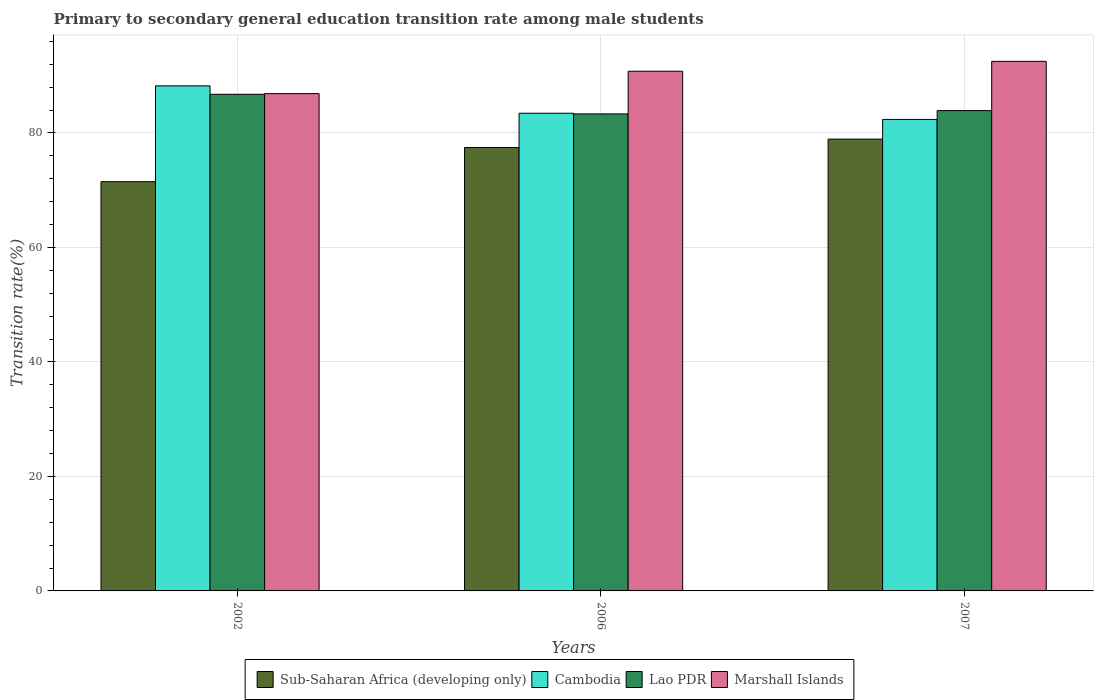How many different coloured bars are there?
Provide a succinct answer. 4. What is the label of the 3rd group of bars from the left?
Make the answer very short. 2007. What is the transition rate in Marshall Islands in 2007?
Provide a succinct answer. 92.51. Across all years, what is the maximum transition rate in Sub-Saharan Africa (developing only)?
Your response must be concise. 78.93. Across all years, what is the minimum transition rate in Marshall Islands?
Give a very brief answer. 86.88. In which year was the transition rate in Cambodia maximum?
Provide a short and direct response. 2002. What is the total transition rate in Marshall Islands in the graph?
Your response must be concise. 270.17. What is the difference between the transition rate in Sub-Saharan Africa (developing only) in 2006 and that in 2007?
Offer a terse response. -1.47. What is the difference between the transition rate in Sub-Saharan Africa (developing only) in 2007 and the transition rate in Cambodia in 2006?
Your answer should be very brief. -4.52. What is the average transition rate in Sub-Saharan Africa (developing only) per year?
Your response must be concise. 75.96. In the year 2002, what is the difference between the transition rate in Sub-Saharan Africa (developing only) and transition rate in Lao PDR?
Provide a short and direct response. -15.27. In how many years, is the transition rate in Cambodia greater than 8 %?
Your answer should be compact. 3. What is the ratio of the transition rate in Cambodia in 2006 to that in 2007?
Your answer should be very brief. 1.01. What is the difference between the highest and the second highest transition rate in Marshall Islands?
Provide a succinct answer. 1.73. What is the difference between the highest and the lowest transition rate in Marshall Islands?
Offer a very short reply. 5.64. In how many years, is the transition rate in Cambodia greater than the average transition rate in Cambodia taken over all years?
Provide a succinct answer. 1. What does the 2nd bar from the left in 2002 represents?
Provide a short and direct response. Cambodia. What does the 1st bar from the right in 2002 represents?
Offer a very short reply. Marshall Islands. Is it the case that in every year, the sum of the transition rate in Marshall Islands and transition rate in Sub-Saharan Africa (developing only) is greater than the transition rate in Cambodia?
Your response must be concise. Yes. How many bars are there?
Make the answer very short. 12. Are all the bars in the graph horizontal?
Your response must be concise. No. Are the values on the major ticks of Y-axis written in scientific E-notation?
Ensure brevity in your answer.  No. Does the graph contain any zero values?
Make the answer very short. No. Does the graph contain grids?
Offer a very short reply. Yes. How are the legend labels stacked?
Your answer should be very brief. Horizontal. What is the title of the graph?
Keep it short and to the point. Primary to secondary general education transition rate among male students. Does "Latvia" appear as one of the legend labels in the graph?
Your response must be concise. No. What is the label or title of the X-axis?
Ensure brevity in your answer.  Years. What is the label or title of the Y-axis?
Ensure brevity in your answer.  Transition rate(%). What is the Transition rate(%) in Sub-Saharan Africa (developing only) in 2002?
Provide a short and direct response. 71.49. What is the Transition rate(%) of Cambodia in 2002?
Provide a succinct answer. 88.23. What is the Transition rate(%) of Lao PDR in 2002?
Ensure brevity in your answer.  86.76. What is the Transition rate(%) in Marshall Islands in 2002?
Provide a short and direct response. 86.88. What is the Transition rate(%) of Sub-Saharan Africa (developing only) in 2006?
Give a very brief answer. 77.46. What is the Transition rate(%) of Cambodia in 2006?
Make the answer very short. 83.45. What is the Transition rate(%) of Lao PDR in 2006?
Your answer should be very brief. 83.33. What is the Transition rate(%) of Marshall Islands in 2006?
Provide a short and direct response. 90.78. What is the Transition rate(%) of Sub-Saharan Africa (developing only) in 2007?
Your answer should be compact. 78.93. What is the Transition rate(%) in Cambodia in 2007?
Ensure brevity in your answer.  82.37. What is the Transition rate(%) of Lao PDR in 2007?
Make the answer very short. 83.91. What is the Transition rate(%) of Marshall Islands in 2007?
Keep it short and to the point. 92.51. Across all years, what is the maximum Transition rate(%) in Sub-Saharan Africa (developing only)?
Your answer should be very brief. 78.93. Across all years, what is the maximum Transition rate(%) of Cambodia?
Make the answer very short. 88.23. Across all years, what is the maximum Transition rate(%) of Lao PDR?
Your answer should be very brief. 86.76. Across all years, what is the maximum Transition rate(%) in Marshall Islands?
Offer a very short reply. 92.51. Across all years, what is the minimum Transition rate(%) in Sub-Saharan Africa (developing only)?
Your response must be concise. 71.49. Across all years, what is the minimum Transition rate(%) in Cambodia?
Provide a short and direct response. 82.37. Across all years, what is the minimum Transition rate(%) in Lao PDR?
Your response must be concise. 83.33. Across all years, what is the minimum Transition rate(%) in Marshall Islands?
Your answer should be very brief. 86.88. What is the total Transition rate(%) of Sub-Saharan Africa (developing only) in the graph?
Your answer should be very brief. 227.88. What is the total Transition rate(%) of Cambodia in the graph?
Give a very brief answer. 254.05. What is the total Transition rate(%) of Lao PDR in the graph?
Make the answer very short. 254. What is the total Transition rate(%) of Marshall Islands in the graph?
Your response must be concise. 270.17. What is the difference between the Transition rate(%) of Sub-Saharan Africa (developing only) in 2002 and that in 2006?
Provide a short and direct response. -5.96. What is the difference between the Transition rate(%) in Cambodia in 2002 and that in 2006?
Your answer should be compact. 4.78. What is the difference between the Transition rate(%) of Lao PDR in 2002 and that in 2006?
Give a very brief answer. 3.43. What is the difference between the Transition rate(%) of Marshall Islands in 2002 and that in 2006?
Offer a very short reply. -3.91. What is the difference between the Transition rate(%) in Sub-Saharan Africa (developing only) in 2002 and that in 2007?
Your response must be concise. -7.44. What is the difference between the Transition rate(%) of Cambodia in 2002 and that in 2007?
Give a very brief answer. 5.86. What is the difference between the Transition rate(%) in Lao PDR in 2002 and that in 2007?
Your answer should be very brief. 2.85. What is the difference between the Transition rate(%) in Marshall Islands in 2002 and that in 2007?
Your answer should be very brief. -5.64. What is the difference between the Transition rate(%) in Sub-Saharan Africa (developing only) in 2006 and that in 2007?
Offer a very short reply. -1.47. What is the difference between the Transition rate(%) of Cambodia in 2006 and that in 2007?
Your answer should be very brief. 1.09. What is the difference between the Transition rate(%) in Lao PDR in 2006 and that in 2007?
Provide a short and direct response. -0.58. What is the difference between the Transition rate(%) in Marshall Islands in 2006 and that in 2007?
Your answer should be very brief. -1.73. What is the difference between the Transition rate(%) of Sub-Saharan Africa (developing only) in 2002 and the Transition rate(%) of Cambodia in 2006?
Your response must be concise. -11.96. What is the difference between the Transition rate(%) in Sub-Saharan Africa (developing only) in 2002 and the Transition rate(%) in Lao PDR in 2006?
Your answer should be compact. -11.84. What is the difference between the Transition rate(%) in Sub-Saharan Africa (developing only) in 2002 and the Transition rate(%) in Marshall Islands in 2006?
Provide a short and direct response. -19.29. What is the difference between the Transition rate(%) in Cambodia in 2002 and the Transition rate(%) in Lao PDR in 2006?
Provide a short and direct response. 4.9. What is the difference between the Transition rate(%) of Cambodia in 2002 and the Transition rate(%) of Marshall Islands in 2006?
Your answer should be very brief. -2.56. What is the difference between the Transition rate(%) of Lao PDR in 2002 and the Transition rate(%) of Marshall Islands in 2006?
Offer a very short reply. -4.03. What is the difference between the Transition rate(%) in Sub-Saharan Africa (developing only) in 2002 and the Transition rate(%) in Cambodia in 2007?
Make the answer very short. -10.87. What is the difference between the Transition rate(%) in Sub-Saharan Africa (developing only) in 2002 and the Transition rate(%) in Lao PDR in 2007?
Provide a short and direct response. -12.42. What is the difference between the Transition rate(%) in Sub-Saharan Africa (developing only) in 2002 and the Transition rate(%) in Marshall Islands in 2007?
Ensure brevity in your answer.  -21.02. What is the difference between the Transition rate(%) in Cambodia in 2002 and the Transition rate(%) in Lao PDR in 2007?
Ensure brevity in your answer.  4.32. What is the difference between the Transition rate(%) of Cambodia in 2002 and the Transition rate(%) of Marshall Islands in 2007?
Provide a succinct answer. -4.28. What is the difference between the Transition rate(%) of Lao PDR in 2002 and the Transition rate(%) of Marshall Islands in 2007?
Make the answer very short. -5.75. What is the difference between the Transition rate(%) in Sub-Saharan Africa (developing only) in 2006 and the Transition rate(%) in Cambodia in 2007?
Make the answer very short. -4.91. What is the difference between the Transition rate(%) in Sub-Saharan Africa (developing only) in 2006 and the Transition rate(%) in Lao PDR in 2007?
Give a very brief answer. -6.45. What is the difference between the Transition rate(%) in Sub-Saharan Africa (developing only) in 2006 and the Transition rate(%) in Marshall Islands in 2007?
Your answer should be compact. -15.05. What is the difference between the Transition rate(%) of Cambodia in 2006 and the Transition rate(%) of Lao PDR in 2007?
Offer a very short reply. -0.46. What is the difference between the Transition rate(%) of Cambodia in 2006 and the Transition rate(%) of Marshall Islands in 2007?
Provide a succinct answer. -9.06. What is the difference between the Transition rate(%) of Lao PDR in 2006 and the Transition rate(%) of Marshall Islands in 2007?
Provide a short and direct response. -9.18. What is the average Transition rate(%) in Sub-Saharan Africa (developing only) per year?
Offer a very short reply. 75.96. What is the average Transition rate(%) in Cambodia per year?
Provide a succinct answer. 84.68. What is the average Transition rate(%) of Lao PDR per year?
Your answer should be compact. 84.67. What is the average Transition rate(%) in Marshall Islands per year?
Offer a terse response. 90.06. In the year 2002, what is the difference between the Transition rate(%) in Sub-Saharan Africa (developing only) and Transition rate(%) in Cambodia?
Give a very brief answer. -16.74. In the year 2002, what is the difference between the Transition rate(%) of Sub-Saharan Africa (developing only) and Transition rate(%) of Lao PDR?
Ensure brevity in your answer.  -15.27. In the year 2002, what is the difference between the Transition rate(%) of Sub-Saharan Africa (developing only) and Transition rate(%) of Marshall Islands?
Offer a very short reply. -15.38. In the year 2002, what is the difference between the Transition rate(%) in Cambodia and Transition rate(%) in Lao PDR?
Provide a short and direct response. 1.47. In the year 2002, what is the difference between the Transition rate(%) in Cambodia and Transition rate(%) in Marshall Islands?
Your answer should be compact. 1.35. In the year 2002, what is the difference between the Transition rate(%) of Lao PDR and Transition rate(%) of Marshall Islands?
Provide a succinct answer. -0.12. In the year 2006, what is the difference between the Transition rate(%) of Sub-Saharan Africa (developing only) and Transition rate(%) of Cambodia?
Give a very brief answer. -5.99. In the year 2006, what is the difference between the Transition rate(%) of Sub-Saharan Africa (developing only) and Transition rate(%) of Lao PDR?
Provide a short and direct response. -5.88. In the year 2006, what is the difference between the Transition rate(%) of Sub-Saharan Africa (developing only) and Transition rate(%) of Marshall Islands?
Give a very brief answer. -13.33. In the year 2006, what is the difference between the Transition rate(%) in Cambodia and Transition rate(%) in Lao PDR?
Ensure brevity in your answer.  0.12. In the year 2006, what is the difference between the Transition rate(%) of Cambodia and Transition rate(%) of Marshall Islands?
Make the answer very short. -7.33. In the year 2006, what is the difference between the Transition rate(%) of Lao PDR and Transition rate(%) of Marshall Islands?
Provide a short and direct response. -7.45. In the year 2007, what is the difference between the Transition rate(%) of Sub-Saharan Africa (developing only) and Transition rate(%) of Cambodia?
Make the answer very short. -3.44. In the year 2007, what is the difference between the Transition rate(%) of Sub-Saharan Africa (developing only) and Transition rate(%) of Lao PDR?
Provide a succinct answer. -4.98. In the year 2007, what is the difference between the Transition rate(%) in Sub-Saharan Africa (developing only) and Transition rate(%) in Marshall Islands?
Your answer should be compact. -13.58. In the year 2007, what is the difference between the Transition rate(%) of Cambodia and Transition rate(%) of Lao PDR?
Keep it short and to the point. -1.54. In the year 2007, what is the difference between the Transition rate(%) in Cambodia and Transition rate(%) in Marshall Islands?
Offer a very short reply. -10.15. In the year 2007, what is the difference between the Transition rate(%) in Lao PDR and Transition rate(%) in Marshall Islands?
Ensure brevity in your answer.  -8.6. What is the ratio of the Transition rate(%) in Sub-Saharan Africa (developing only) in 2002 to that in 2006?
Your answer should be compact. 0.92. What is the ratio of the Transition rate(%) in Cambodia in 2002 to that in 2006?
Offer a terse response. 1.06. What is the ratio of the Transition rate(%) of Lao PDR in 2002 to that in 2006?
Make the answer very short. 1.04. What is the ratio of the Transition rate(%) in Marshall Islands in 2002 to that in 2006?
Offer a terse response. 0.96. What is the ratio of the Transition rate(%) in Sub-Saharan Africa (developing only) in 2002 to that in 2007?
Keep it short and to the point. 0.91. What is the ratio of the Transition rate(%) in Cambodia in 2002 to that in 2007?
Provide a short and direct response. 1.07. What is the ratio of the Transition rate(%) in Lao PDR in 2002 to that in 2007?
Ensure brevity in your answer.  1.03. What is the ratio of the Transition rate(%) of Marshall Islands in 2002 to that in 2007?
Provide a succinct answer. 0.94. What is the ratio of the Transition rate(%) in Sub-Saharan Africa (developing only) in 2006 to that in 2007?
Your answer should be very brief. 0.98. What is the ratio of the Transition rate(%) of Cambodia in 2006 to that in 2007?
Make the answer very short. 1.01. What is the ratio of the Transition rate(%) in Marshall Islands in 2006 to that in 2007?
Ensure brevity in your answer.  0.98. What is the difference between the highest and the second highest Transition rate(%) in Sub-Saharan Africa (developing only)?
Your response must be concise. 1.47. What is the difference between the highest and the second highest Transition rate(%) in Cambodia?
Keep it short and to the point. 4.78. What is the difference between the highest and the second highest Transition rate(%) of Lao PDR?
Make the answer very short. 2.85. What is the difference between the highest and the second highest Transition rate(%) in Marshall Islands?
Give a very brief answer. 1.73. What is the difference between the highest and the lowest Transition rate(%) of Sub-Saharan Africa (developing only)?
Offer a terse response. 7.44. What is the difference between the highest and the lowest Transition rate(%) in Cambodia?
Give a very brief answer. 5.86. What is the difference between the highest and the lowest Transition rate(%) of Lao PDR?
Ensure brevity in your answer.  3.43. What is the difference between the highest and the lowest Transition rate(%) in Marshall Islands?
Keep it short and to the point. 5.64. 